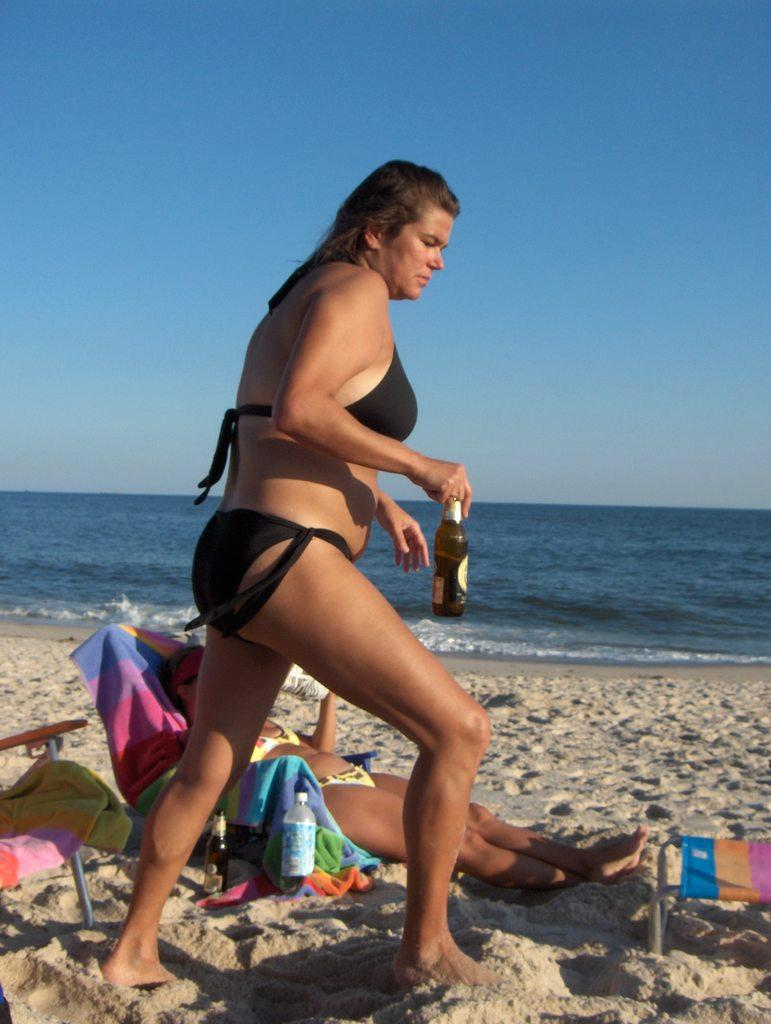What is the woman in the foreground of the image doing? The woman is standing in the image and holding a bottle in her hand. Can you describe the woman in the background of the image? The woman in the background is sleeping. What type of environment is visible in the background of the image? Sand, water, and the sky are visible in the background of the image. What type of stone can be seen being used as a channel in the image? There is no stone or channel present in the image. What event is being celebrated in the image? The image does not depict any specific event or celebration. 